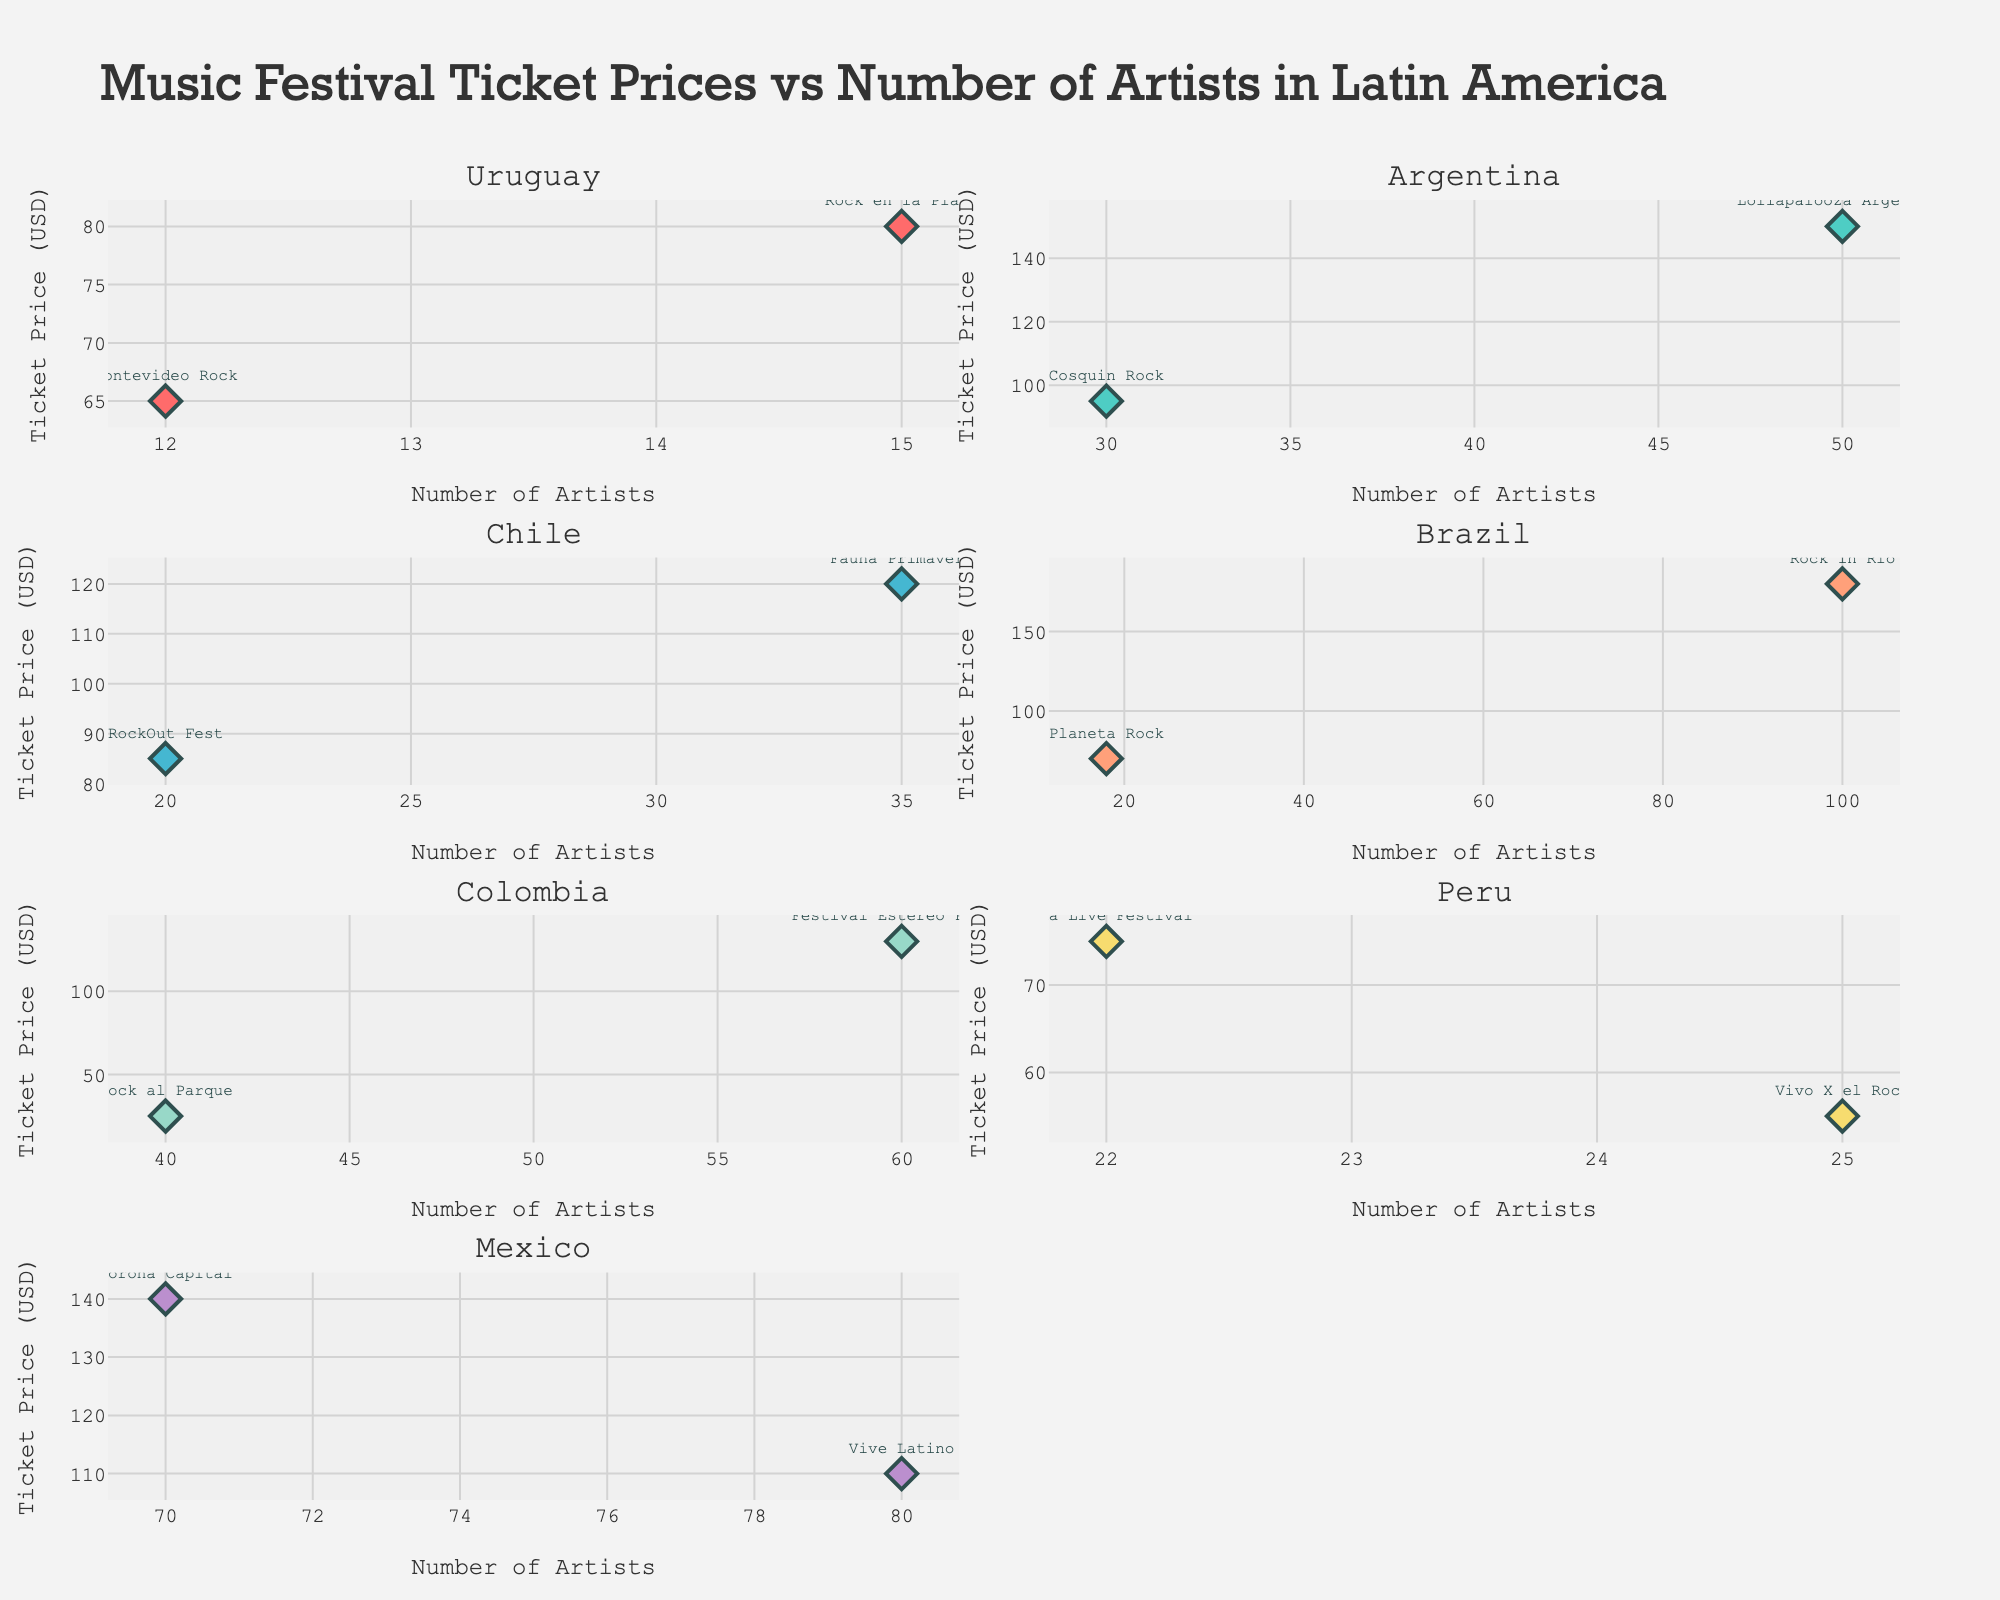What is the title of the plot? The title of the plot is displayed at the top center of the figure to summarize the content and purpose of the visualization. It usually provides insight into what data is being presented.
Answer: Music Festival Ticket Prices vs Number of Artists in Latin America How many countries are represented in the subplot? Each subplot title represents a different country. Counting these titles gives the total number of countries represented.
Answer: 7 Which country has the festival with the highest ticket price? By looking at the y-axis (Ticket Price) across all subplots, the highest point indicates the highest ticket price. Locate the highest point and check its corresponding subplot (country).
Answer: Brazil How many music festivals are there in Argentina? By examining the number of data points in the scatter plots for the Argentina subplot, we can count the festivals.
Answer: 2 In which country is the festival with the lowest ticket price, and what is the price? By identifying the lowest point on the y-axis across all subplots and checking its corresponding subplot (country) and y-axis value (ticket price).
Answer: Colombia, 25 Which country has the most diverse range of ticket prices? By comparing the spread of data points along the y-axis (Ticket Price) for each country, the country with the widest range in values has the most diverse range.
Answer: Brazil Are there any countries where all festivals have a similar number of performing artists? By checking if the data points in any subplot lie close to each other on the x-axis (Number of Artists), implying a similar number of artists.
Answer: Yes, Uruguay Which festival in Mexico has the highest number of performing artists, and what is the number? By looking at the data points in the Mexico subplot and finding the highest value on the x-axis (Number of Artists), then identifying the corresponding festival.
Answer: Vive Latino, 80 